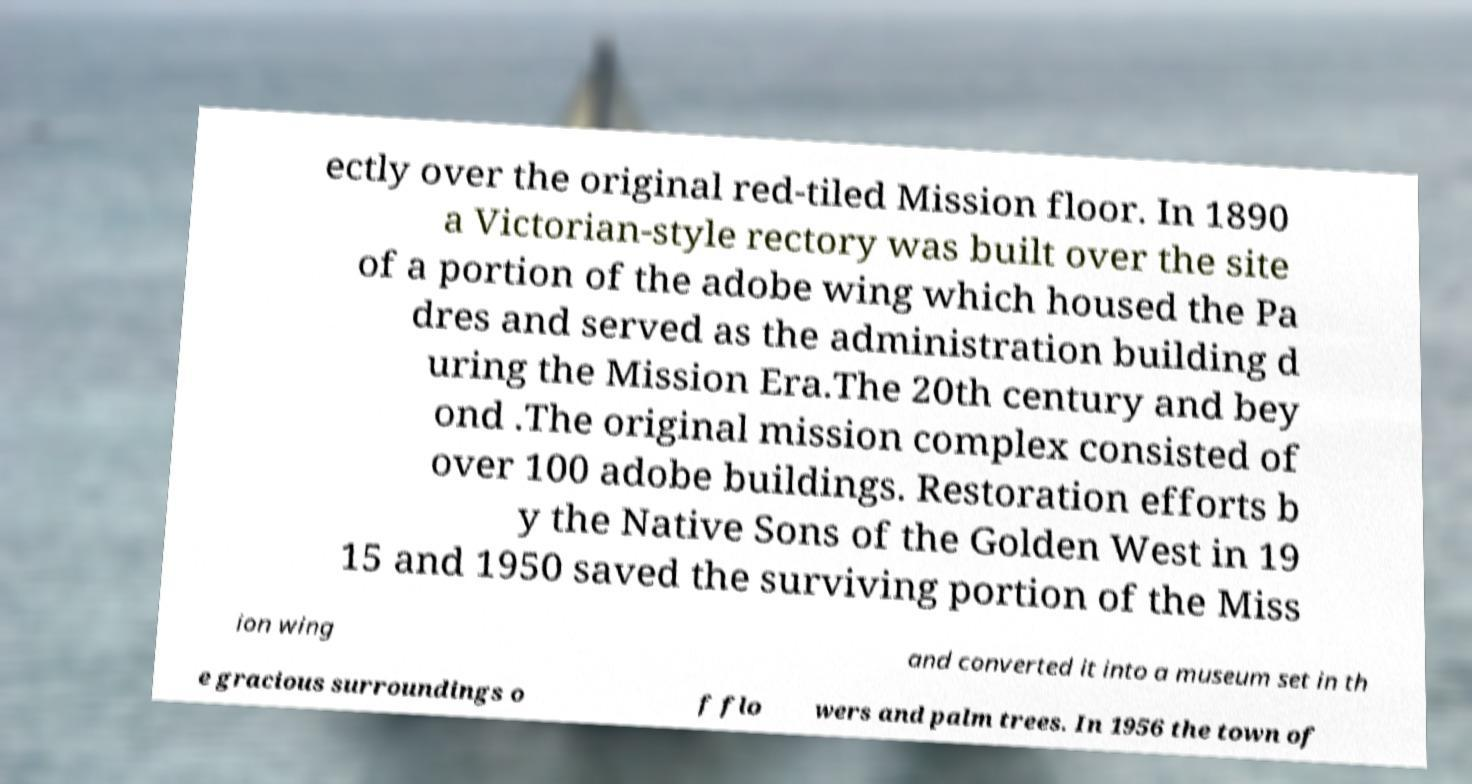Could you assist in decoding the text presented in this image and type it out clearly? ectly over the original red-tiled Mission floor. In 1890 a Victorian-style rectory was built over the site of a portion of the adobe wing which housed the Pa dres and served as the administration building d uring the Mission Era.The 20th century and bey ond .The original mission complex consisted of over 100 adobe buildings. Restoration efforts b y the Native Sons of the Golden West in 19 15 and 1950 saved the surviving portion of the Miss ion wing and converted it into a museum set in th e gracious surroundings o f flo wers and palm trees. In 1956 the town of 